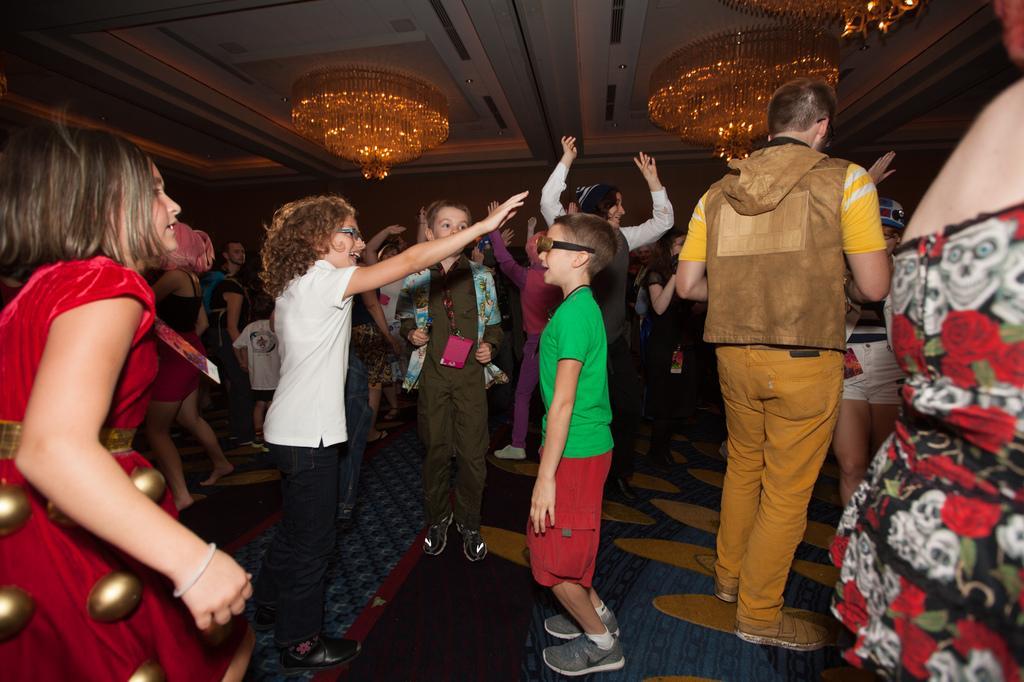Can you describe this image briefly? In the picture we can see group of people standing and top of the picture there is roof. 